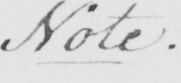What text is written in this handwritten line? Note . 